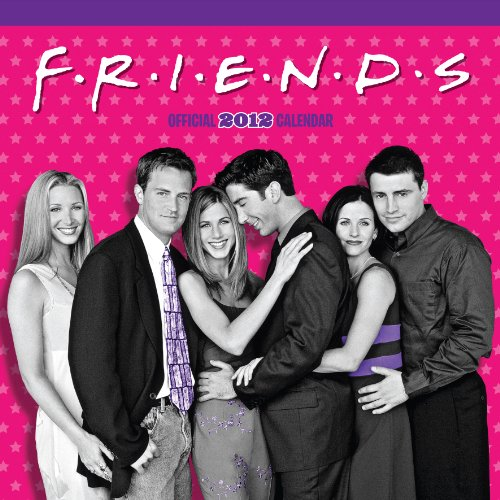Is this a romantic book? No, this is not a romantic book; it's actually a themed calendar for the year 2012 featuring moments from the TV show 'Friends'. 